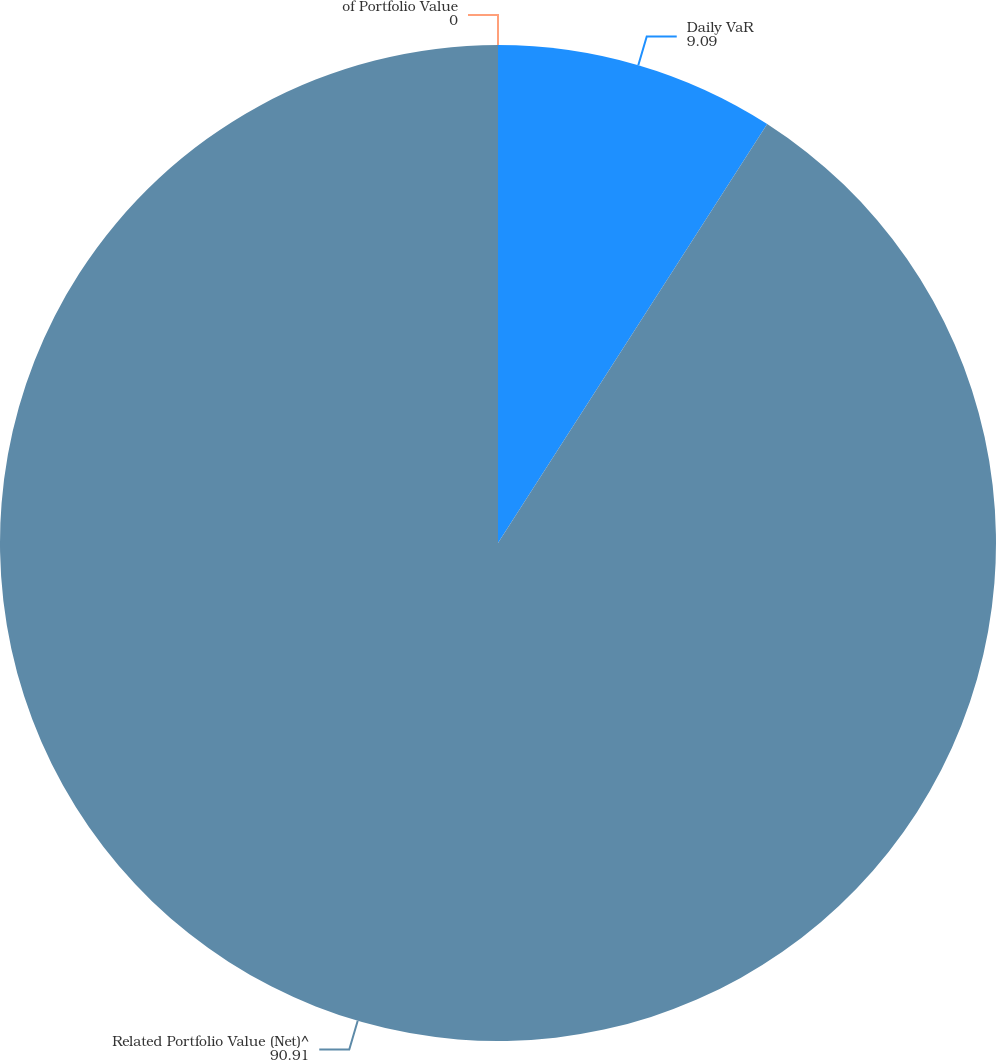Convert chart. <chart><loc_0><loc_0><loc_500><loc_500><pie_chart><fcel>Daily VaR<fcel>Related Portfolio Value (Net)^<fcel>of Portfolio Value<nl><fcel>9.09%<fcel>90.91%<fcel>0.0%<nl></chart> 